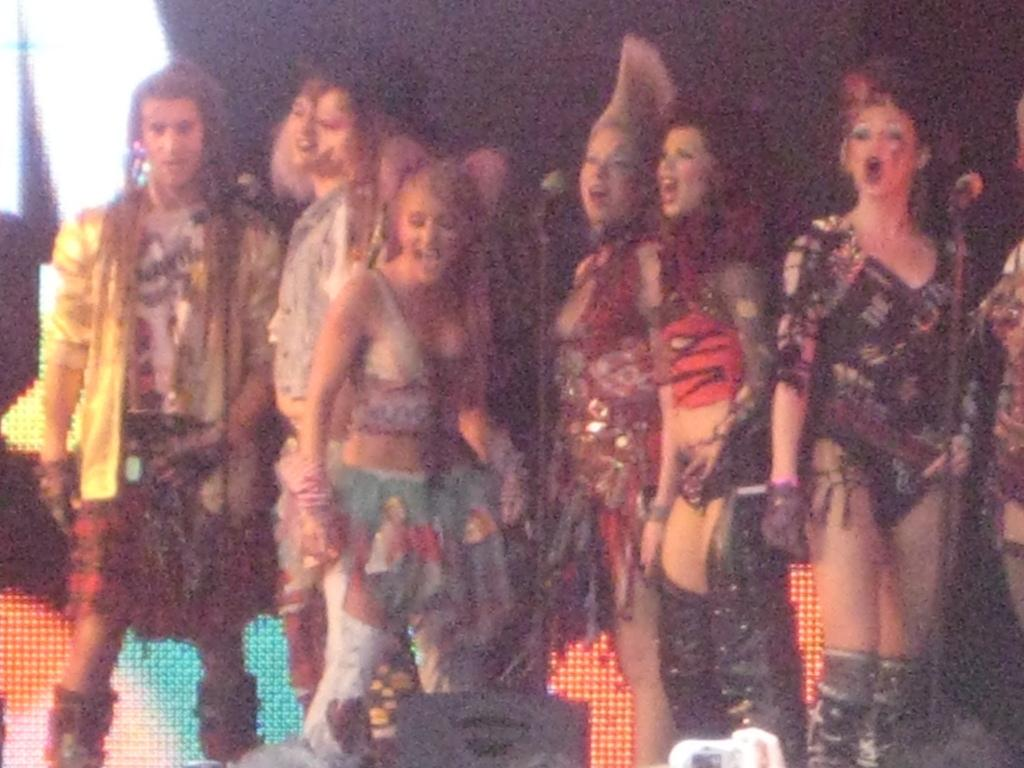What is the main subject in the middle of the image? There is a group of girls in the middle of the image. What are the girls wearing? The girls are wearing costumes. What can be seen on the left side of the image? There are men on the left side of the image. What are the men doing? The men are shouting. What number is being shouted by the men in the image? There is no specific number mentioned in the image; the men are simply shouting. 